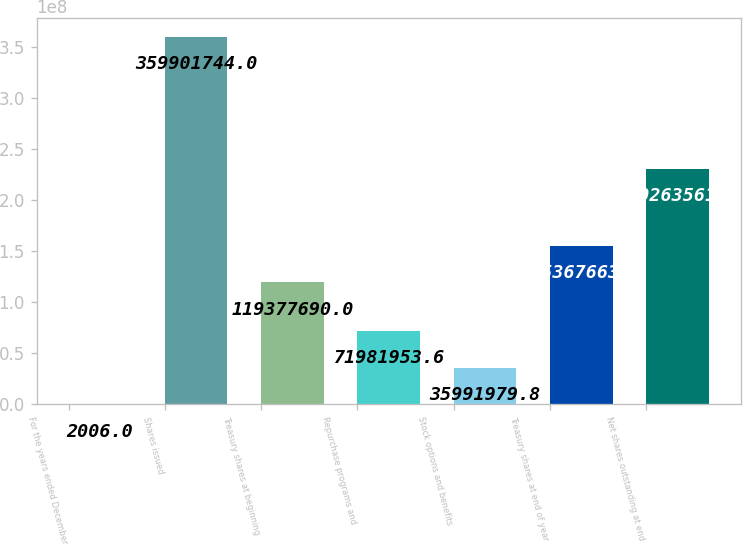Convert chart. <chart><loc_0><loc_0><loc_500><loc_500><bar_chart><fcel>For the years ended December<fcel>Shares issued<fcel>Treasury shares at beginning<fcel>Repurchase programs and<fcel>Stock options and benefits<fcel>Treasury shares at end of year<fcel>Net shares outstanding at end<nl><fcel>2006<fcel>3.59902e+08<fcel>1.19378e+08<fcel>7.1982e+07<fcel>3.5992e+07<fcel>1.55368e+08<fcel>2.30264e+08<nl></chart> 